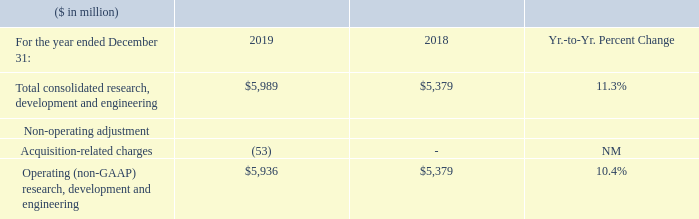Research, Development and Engineering Expense
NM—Not meaningful
Research, development and engineering (RD&E) expense was 7.8 percent of revenue in 2019 and 6.8 percent of revenue in 2018.
RD&E expense increased 11.3 percent in 2019 versus 2018 primarily driven by: • Higher spending (11 points) including investment in the z15 and Red Hat spending in the second half of 2019 (8 points); and • Higher acquisition-related charges associated with the Red Hat transaction (1 point); partially offset by • The effects of currency (1 point).
Operating (non-GAAP) expense increased 10.4 percent year to year primarily driven by the same factors excluding the acquisition-related charges associated with the Red Hat transaction.
What percentage of total revenue was Research, development and engineering (RD&E) expenses? Research, development and engineering (rd&e) expense was 7.8 percent of revenue in 2019 and 6.8 percent of revenue in 2018. What caused the increase in the RD&E expenses? Rd&e expense increased 11.3 percent in 2019 versus 2018 primarily driven by: • higher spending (11 points) including investment in the z15 and red hat spending in the second half of 2019 (8 points); and • higher acquisition-related charges associated with the red hat transaction (1 point); partially offset by • the effects of currency (1 point). What caused the Operating (non-GAAP) expense increase? Operating (non-gaap) expense increased 10.4 percent year to year primarily driven by the same factors excluding the acquisition-related charges associated with the red hat transaction. What was the increase / (decrease) in the Total consolidated research, development and engineering from 2018 to 2019?
Answer scale should be: million. 5,989 - 5,379
Answer: 610. What was the average Acquisition-related charges?
Answer scale should be: million. (-53 + 0) / 2
Answer: -26.5. What was the Operating (non-GAAP) research, development and engineering average?
Answer scale should be: million. (5,936 + 5,379) / 2
Answer: 5657.5. 